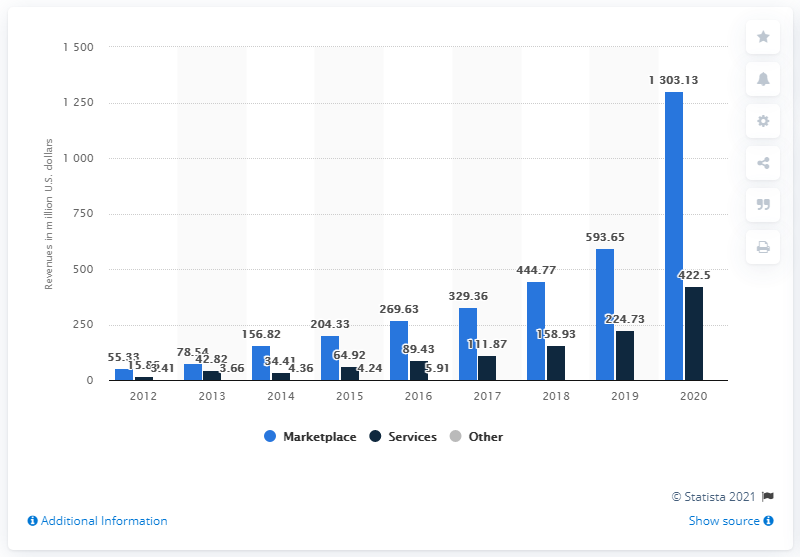Identify some key points in this picture. Etsy generated $422.5 million in marketplace revenues in 2020. 